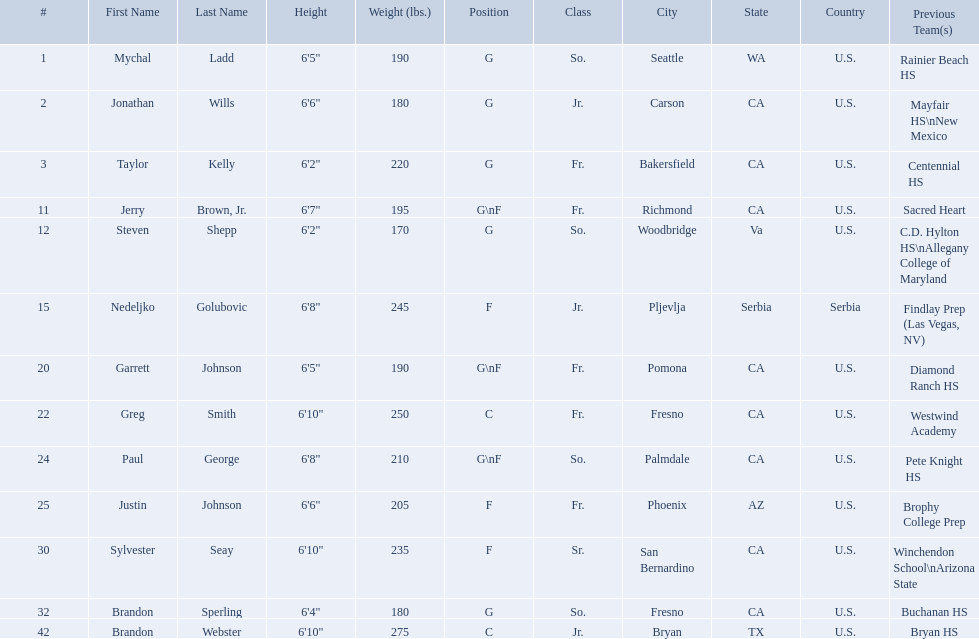What class was each team member in for the 2009-10 fresno state bulldogs? So., Jr., Fr., Fr., So., Jr., Fr., Fr., So., Fr., Sr., So., Jr. Which of these was outside of the us? Jr. Who was the player? Nedeljko Golubovic. What are the listed classes of the players? So., Jr., Fr., Fr., So., Jr., Fr., Fr., So., Fr., Sr., So., Jr. Which of these is not from the us? Jr. To which name does that entry correspond to? Nedeljko Golubovic. What are the names for all players? Mychal Ladd, Jonathan Wills, Taylor Kelly, Jerry Brown, Jr., Steven Shepp, Nedeljko Golubovic, Garrett Johnson, Greg Smith, Paul George, Justin Johnson, Sylvester Seay, Brandon Sperling, Brandon Webster. Which players are taller than 6'8? Nedeljko Golubovic, Greg Smith, Paul George, Sylvester Seay, Brandon Webster. How tall is paul george? 6'8". How tall is greg smith? 6'10". Of these two, which it tallest? Greg Smith. Who are all the players? Mychal Ladd, Jonathan Wills, Taylor Kelly, Jerry Brown, Jr., Steven Shepp, Nedeljko Golubovic, Garrett Johnson, Greg Smith, Paul George, Justin Johnson, Sylvester Seay, Brandon Sperling, Brandon Webster. How tall are they? 6'5", 6'6", 6'2", 6'7", 6'2", 6'8", 6'5", 6'10", 6'8", 6'6", 6'10", 6'4", 6'10". What about just paul george and greg smitih? 6'10", 6'8". And which of the two is taller? Greg Smith. 